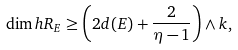<formula> <loc_0><loc_0><loc_500><loc_500>\dim h R _ { E } \geq \left ( 2 d ( E ) + \frac { 2 } { \eta - 1 } \right ) \wedge k ,</formula> 